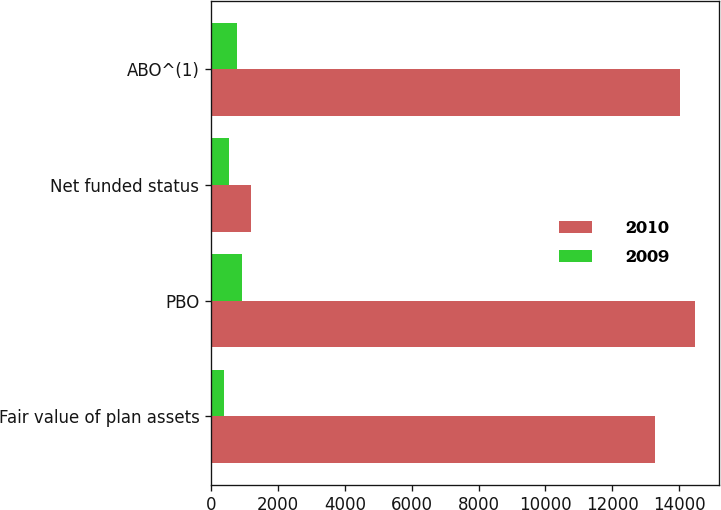Convert chart to OTSL. <chart><loc_0><loc_0><loc_500><loc_500><stacked_bar_chart><ecel><fcel>Fair value of plan assets<fcel>PBO<fcel>Net funded status<fcel>ABO^(1)<nl><fcel>2010<fcel>13295<fcel>14484<fcel>1189<fcel>14014<nl><fcel>2009<fcel>375<fcel>923<fcel>548<fcel>778<nl></chart> 